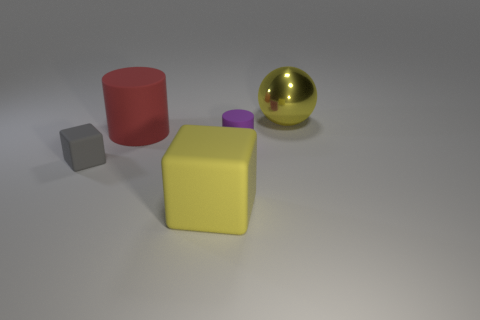Subtract all yellow cubes. How many cubes are left? 1 Subtract all cubes. How many objects are left? 3 Subtract 1 cylinders. How many cylinders are left? 1 Subtract all gray cylinders. How many red balls are left? 0 Add 4 big yellow rubber objects. How many big yellow rubber objects exist? 5 Add 1 rubber blocks. How many objects exist? 6 Subtract 1 yellow cubes. How many objects are left? 4 Subtract all blue spheres. Subtract all brown cubes. How many spheres are left? 1 Subtract all large objects. Subtract all large balls. How many objects are left? 1 Add 3 small purple rubber cylinders. How many small purple rubber cylinders are left? 4 